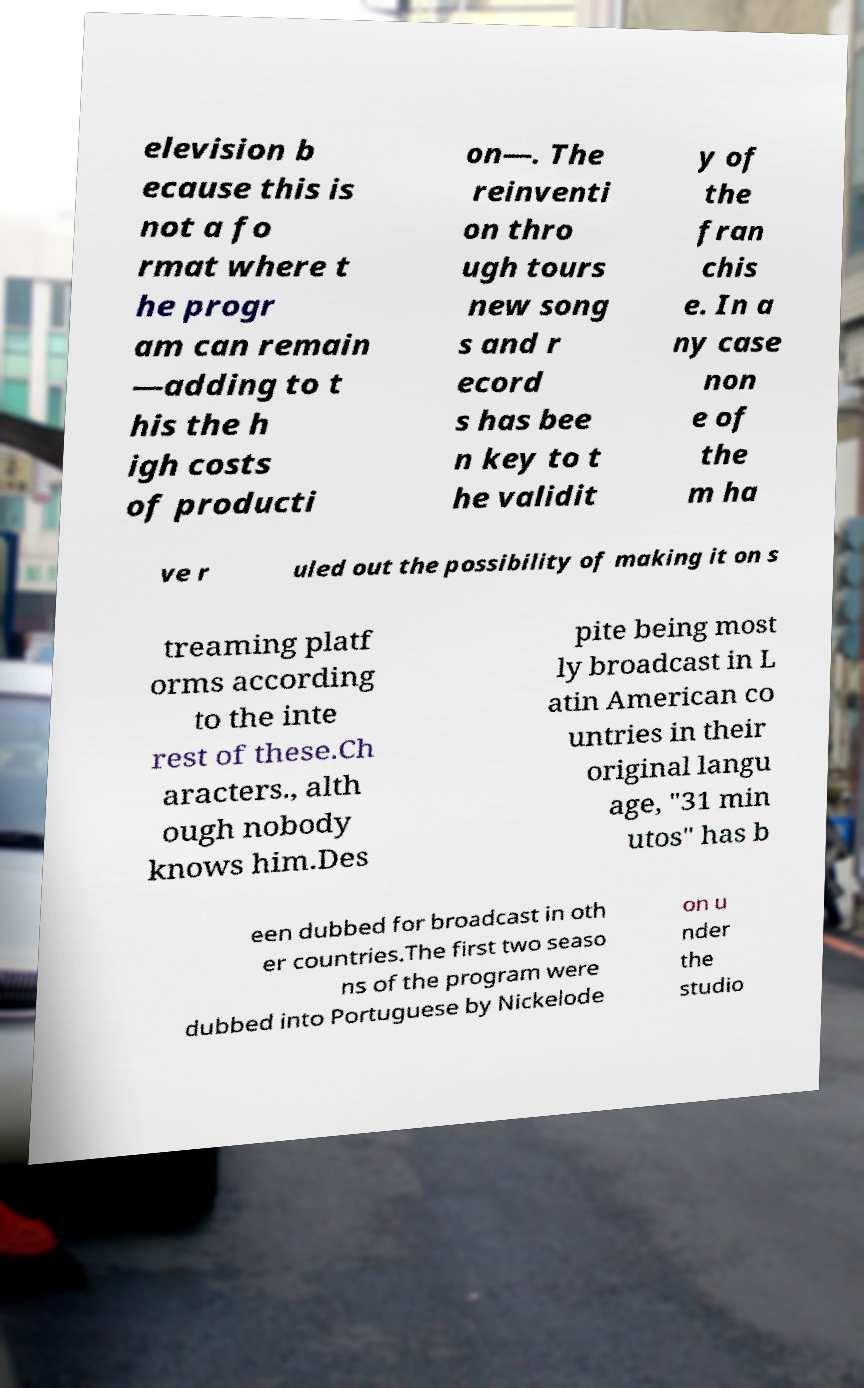There's text embedded in this image that I need extracted. Can you transcribe it verbatim? elevision b ecause this is not a fo rmat where t he progr am can remain —adding to t his the h igh costs of producti on—. The reinventi on thro ugh tours new song s and r ecord s has bee n key to t he validit y of the fran chis e. In a ny case non e of the m ha ve r uled out the possibility of making it on s treaming platf orms according to the inte rest of these.Ch aracters., alth ough nobody knows him.Des pite being most ly broadcast in L atin American co untries in their original langu age, "31 min utos" has b een dubbed for broadcast in oth er countries.The first two seaso ns of the program were dubbed into Portuguese by Nickelode on u nder the studio 